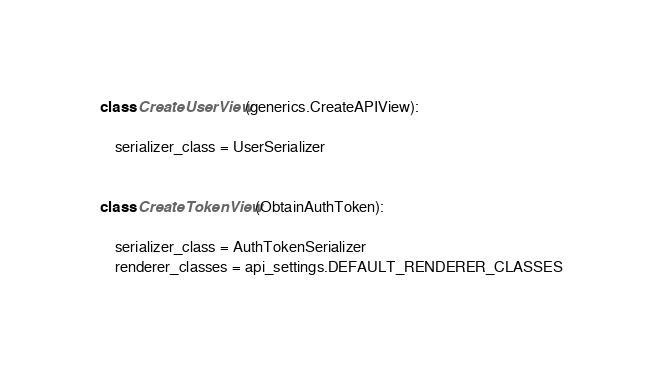Convert code to text. <code><loc_0><loc_0><loc_500><loc_500><_Python_>
class CreateUserView(generics.CreateAPIView):

    serializer_class = UserSerializer


class CreateTokenView(ObtainAuthToken):

    serializer_class = AuthTokenSerializer
    renderer_classes = api_settings.DEFAULT_RENDERER_CLASSES</code> 